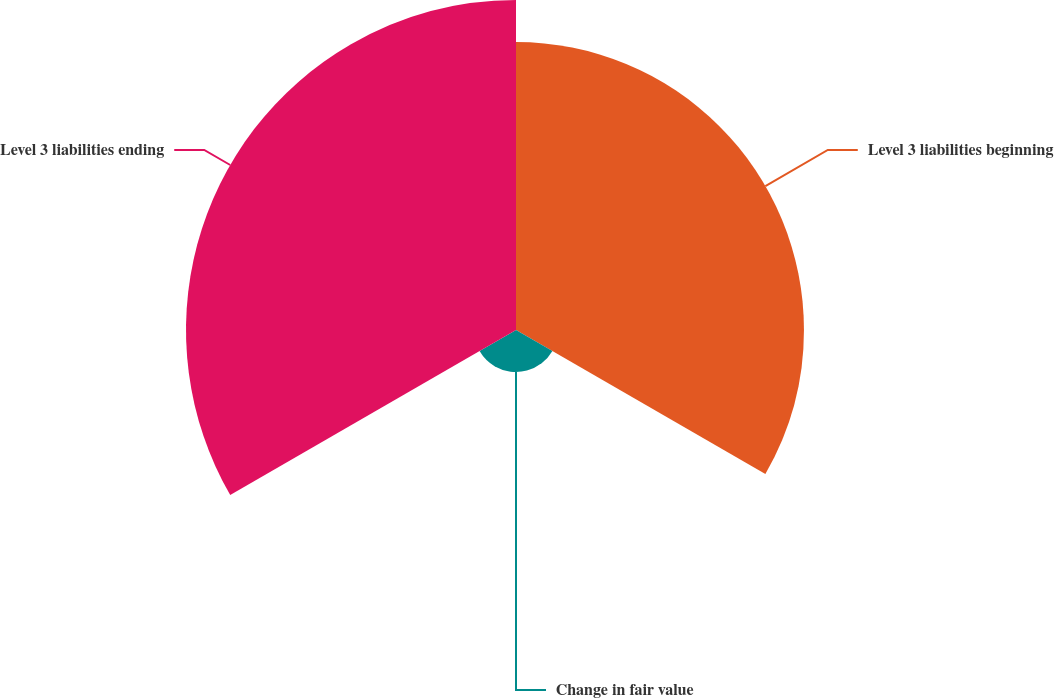Convert chart. <chart><loc_0><loc_0><loc_500><loc_500><pie_chart><fcel>Level 3 liabilities beginning<fcel>Change in fair value<fcel>Level 3 liabilities ending<nl><fcel>43.63%<fcel>6.37%<fcel>50.0%<nl></chart> 